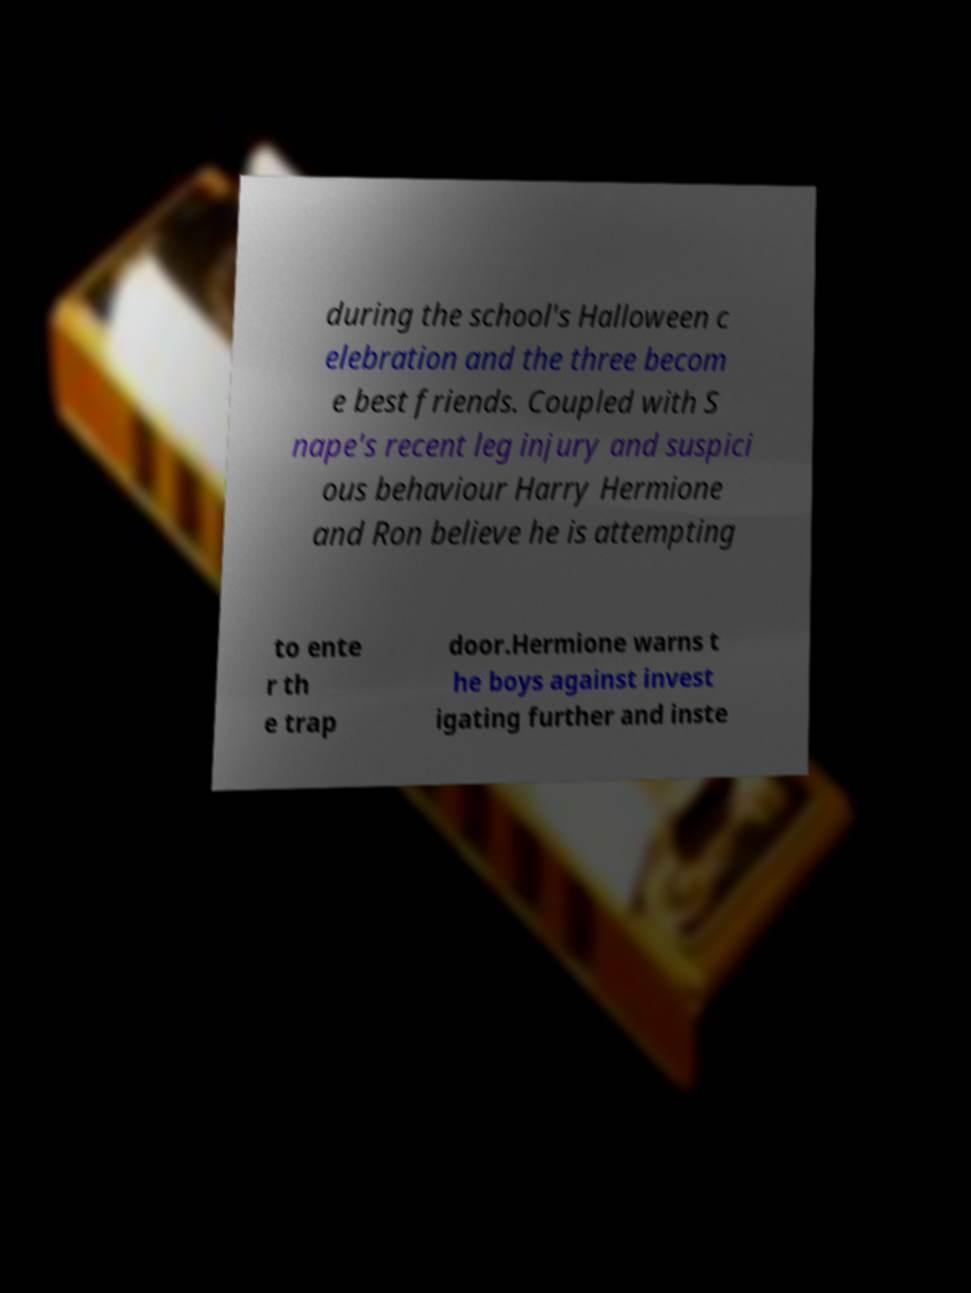Can you read and provide the text displayed in the image?This photo seems to have some interesting text. Can you extract and type it out for me? during the school's Halloween c elebration and the three becom e best friends. Coupled with S nape's recent leg injury and suspici ous behaviour Harry Hermione and Ron believe he is attempting to ente r th e trap door.Hermione warns t he boys against invest igating further and inste 